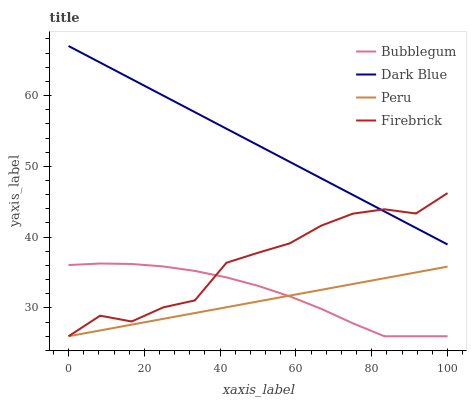Does Firebrick have the minimum area under the curve?
Answer yes or no. No. Does Firebrick have the maximum area under the curve?
Answer yes or no. No. Is Firebrick the smoothest?
Answer yes or no. No. Is Peru the roughest?
Answer yes or no. No. Does Firebrick have the highest value?
Answer yes or no. No. Is Bubblegum less than Dark Blue?
Answer yes or no. Yes. Is Dark Blue greater than Peru?
Answer yes or no. Yes. Does Bubblegum intersect Dark Blue?
Answer yes or no. No. 